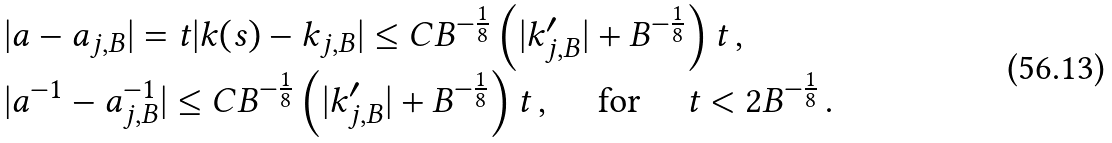<formula> <loc_0><loc_0><loc_500><loc_500>\begin{array} { l } | a - a _ { j , B } | = t | k ( s ) - k _ { j , B } | \leq C B ^ { - \frac { 1 } { 8 } } \left ( | k _ { j , B } ^ { \prime } | + B ^ { - \frac { 1 } { 8 } } \right ) t \, , \\ | a ^ { - 1 } - a _ { j , B } ^ { - 1 } | \leq C B ^ { - \frac { 1 } { 8 } } \left ( | k _ { j , B } ^ { \prime } | + B ^ { - \frac { 1 } { 8 } } \right ) t \, , \quad \text { for } \quad t < 2 B ^ { - \frac { 1 } { 8 } } \, . \end{array}</formula> 